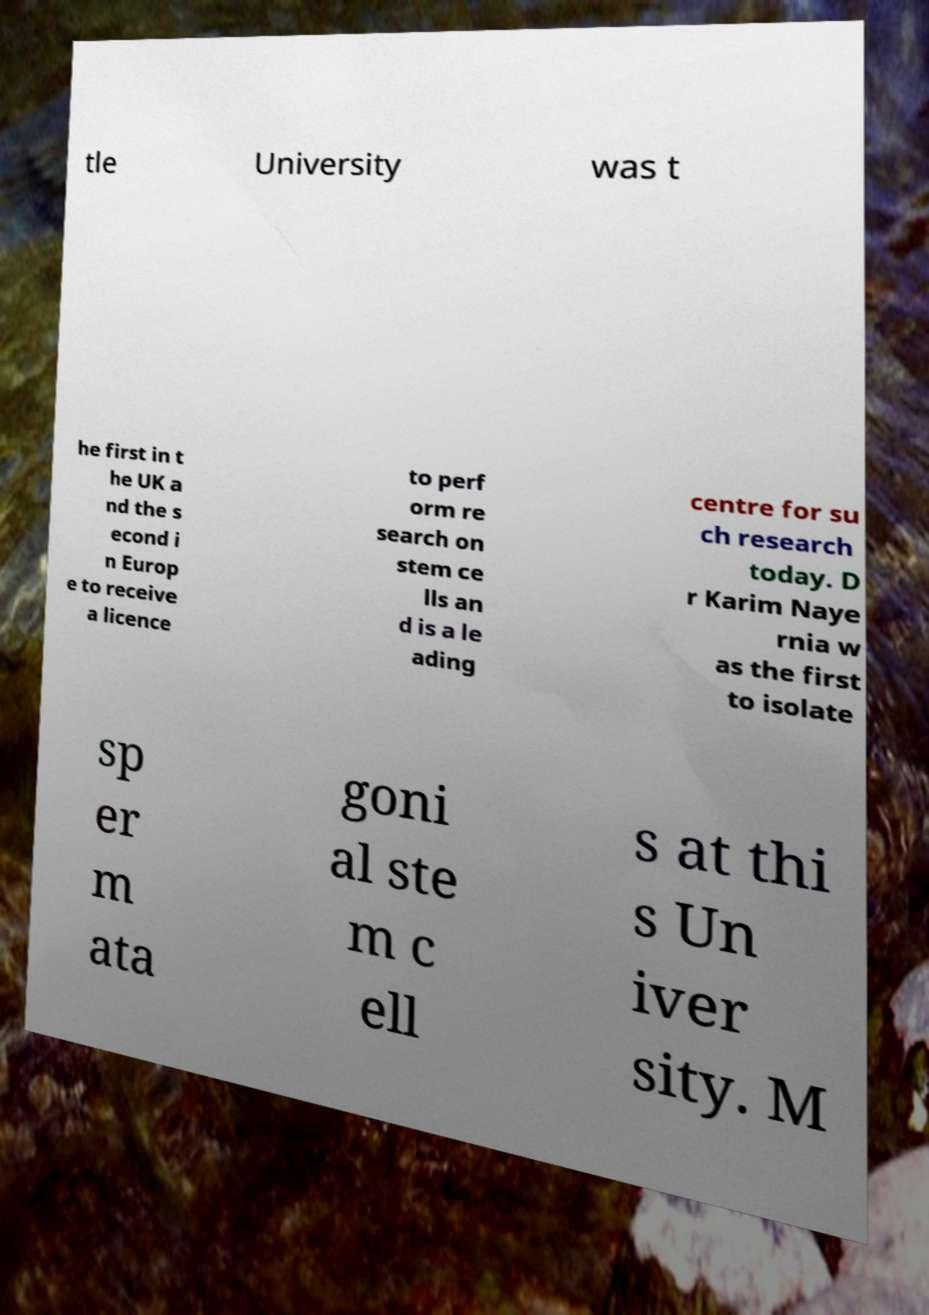What messages or text are displayed in this image? I need them in a readable, typed format. tle University was t he first in t he UK a nd the s econd i n Europ e to receive a licence to perf orm re search on stem ce lls an d is a le ading centre for su ch research today. D r Karim Naye rnia w as the first to isolate sp er m ata goni al ste m c ell s at thi s Un iver sity. M 